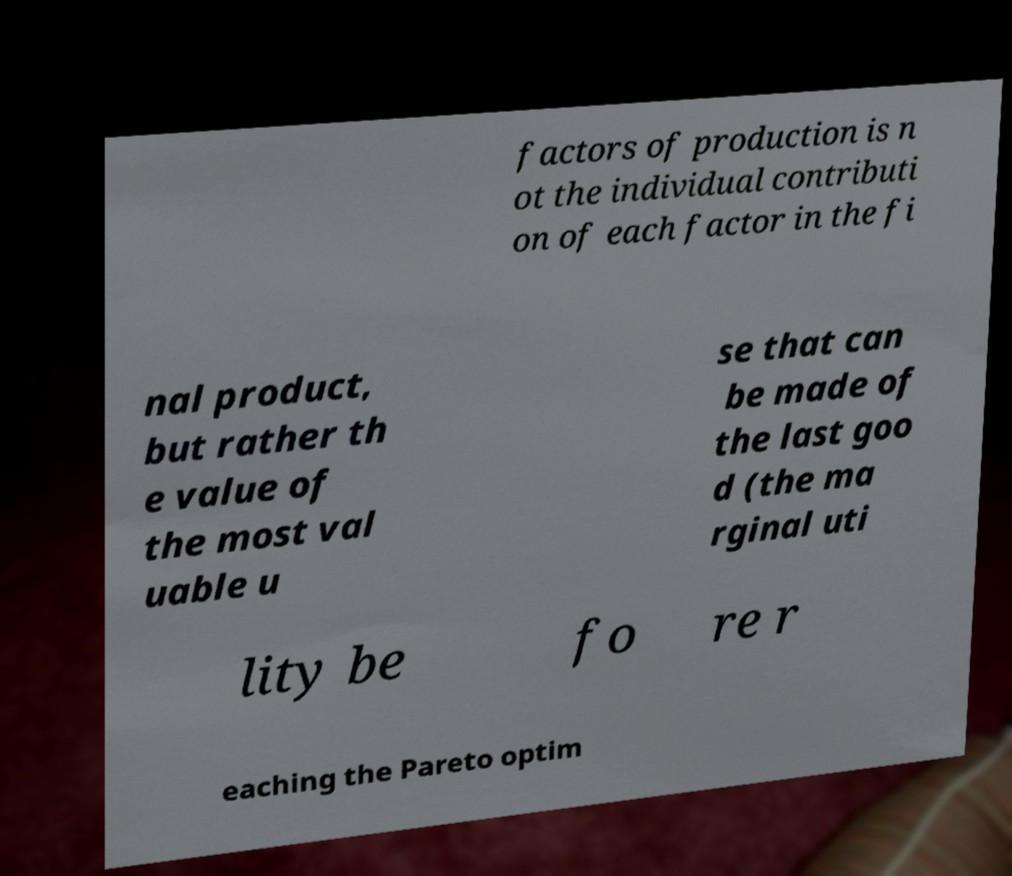Could you assist in decoding the text presented in this image and type it out clearly? factors of production is n ot the individual contributi on of each factor in the fi nal product, but rather th e value of the most val uable u se that can be made of the last goo d (the ma rginal uti lity be fo re r eaching the Pareto optim 